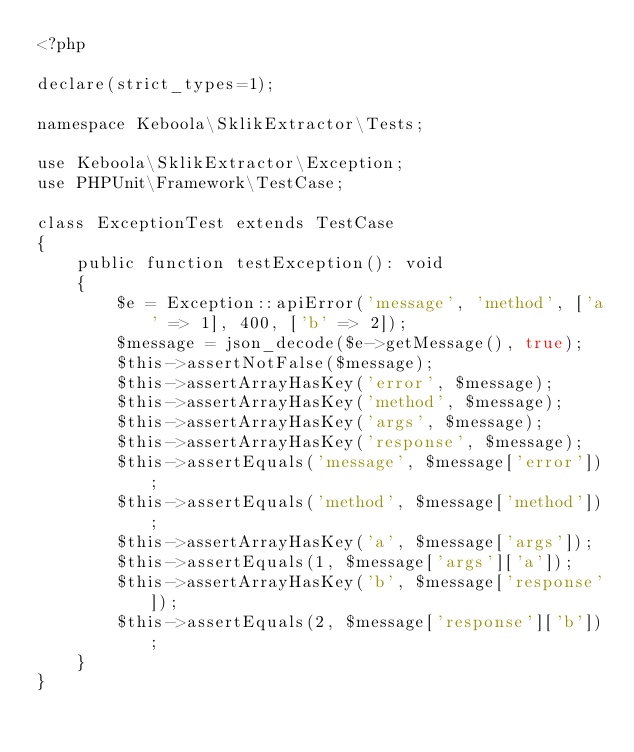Convert code to text. <code><loc_0><loc_0><loc_500><loc_500><_PHP_><?php

declare(strict_types=1);

namespace Keboola\SklikExtractor\Tests;

use Keboola\SklikExtractor\Exception;
use PHPUnit\Framework\TestCase;

class ExceptionTest extends TestCase
{
    public function testException(): void
    {
        $e = Exception::apiError('message', 'method', ['a' => 1], 400, ['b' => 2]);
        $message = json_decode($e->getMessage(), true);
        $this->assertNotFalse($message);
        $this->assertArrayHasKey('error', $message);
        $this->assertArrayHasKey('method', $message);
        $this->assertArrayHasKey('args', $message);
        $this->assertArrayHasKey('response', $message);
        $this->assertEquals('message', $message['error']);
        $this->assertEquals('method', $message['method']);
        $this->assertArrayHasKey('a', $message['args']);
        $this->assertEquals(1, $message['args']['a']);
        $this->assertArrayHasKey('b', $message['response']);
        $this->assertEquals(2, $message['response']['b']);
    }
}
</code> 